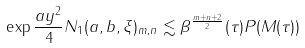Convert formula to latex. <formula><loc_0><loc_0><loc_500><loc_500>\| \exp { \frac { a y ^ { 2 } } { 4 } } N _ { 1 } ( a , b , \xi ) \| _ { m , n } \lesssim \beta ^ { \frac { m + n + 2 } { 2 } } ( \tau ) P ( M ( \tau ) )</formula> 